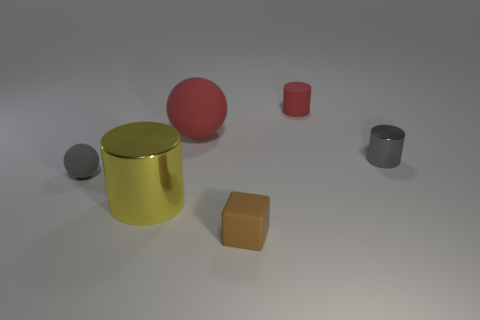Add 2 red matte spheres. How many objects exist? 8 Subtract all blocks. How many objects are left? 5 Add 5 large green things. How many large green things exist? 5 Subtract 1 brown cubes. How many objects are left? 5 Subtract all spheres. Subtract all tiny red rubber objects. How many objects are left? 3 Add 3 large red rubber objects. How many large red rubber objects are left? 4 